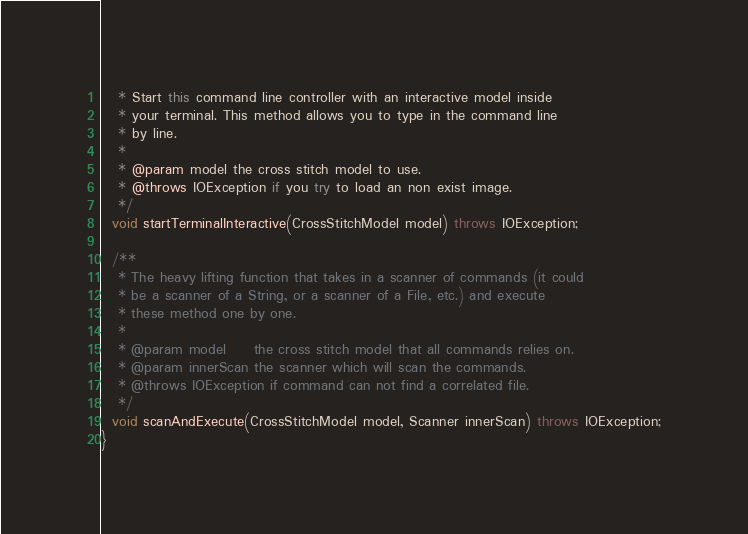Convert code to text. <code><loc_0><loc_0><loc_500><loc_500><_Java_>   * Start this command line controller with an interactive model inside
   * your terminal. This method allows you to type in the command line
   * by line.
   *
   * @param model the cross stitch model to use.
   * @throws IOException if you try to load an non exist image.
   */
  void startTerminalInteractive(CrossStitchModel model) throws IOException;

  /**
   * The heavy lifting function that takes in a scanner of commands (it could
   * be a scanner of a String, or a scanner of a File, etc.) and execute
   * these method one by one.
   *
   * @param model     the cross stitch model that all commands relies on.
   * @param innerScan the scanner which will scan the commands.
   * @throws IOException if command can not find a correlated file.
   */
  void scanAndExecute(CrossStitchModel model, Scanner innerScan) throws IOException;
}
</code> 